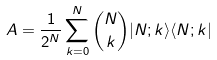<formula> <loc_0><loc_0><loc_500><loc_500>A = \frac { 1 } { 2 ^ { N } } \sum _ { k = 0 } ^ { N } { N \choose k } | N ; k \rangle \langle N ; k |</formula> 